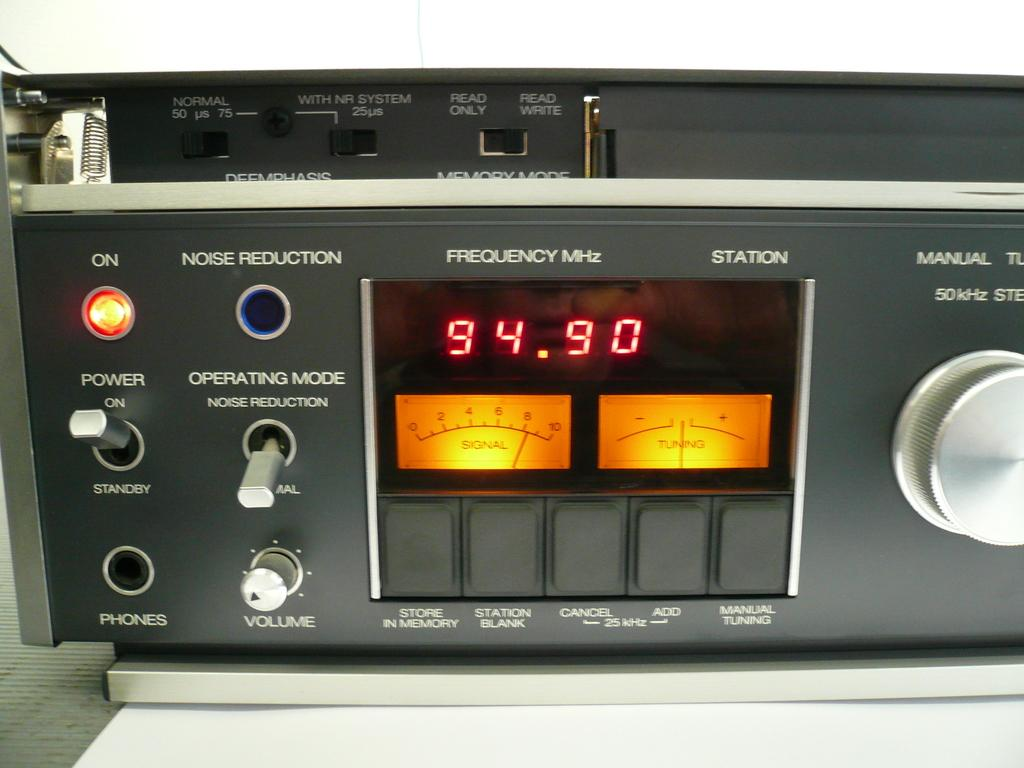<image>
Create a compact narrative representing the image presented. A piece of radio machinery shows the current frequency at 94.90. 